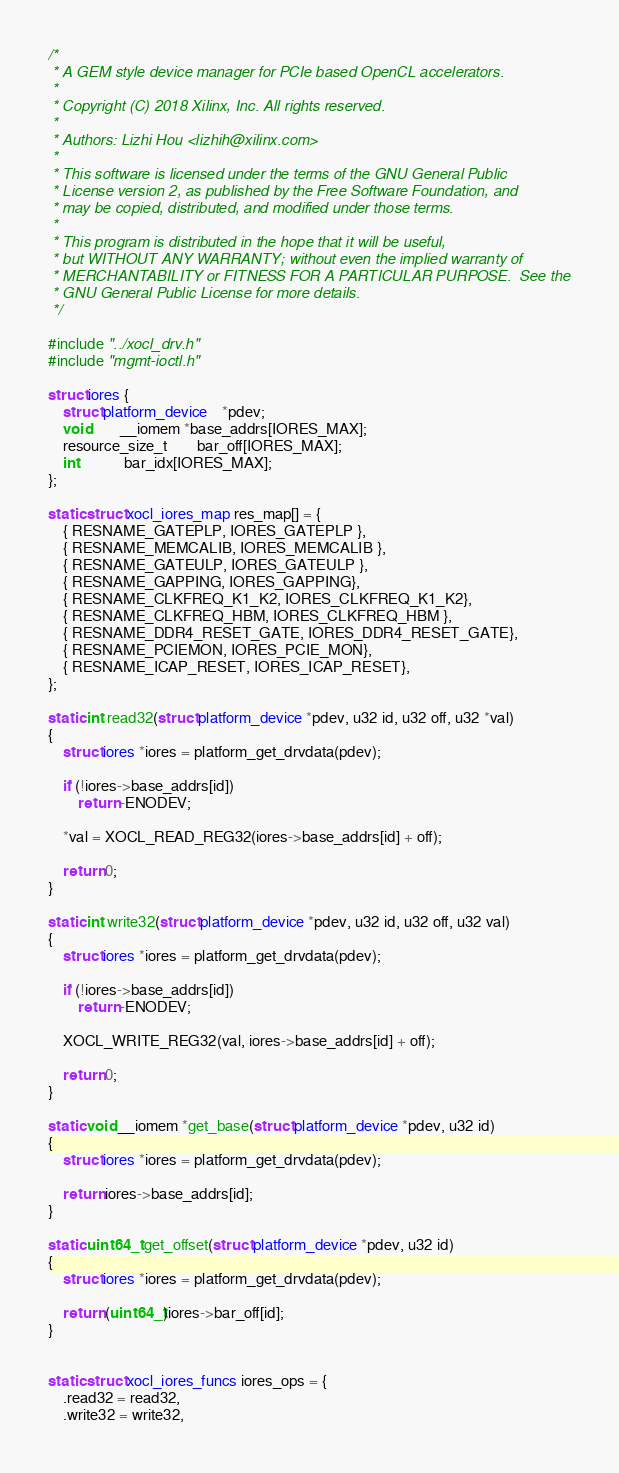<code> <loc_0><loc_0><loc_500><loc_500><_C_>/*
 * A GEM style device manager for PCIe based OpenCL accelerators.
 *
 * Copyright (C) 2018 Xilinx, Inc. All rights reserved.
 *
 * Authors: Lizhi Hou <lizhih@xilinx.com>
 *
 * This software is licensed under the terms of the GNU General Public
 * License version 2, as published by the Free Software Foundation, and
 * may be copied, distributed, and modified under those terms.
 *
 * This program is distributed in the hope that it will be useful,
 * but WITHOUT ANY WARRANTY; without even the implied warranty of
 * MERCHANTABILITY or FITNESS FOR A PARTICULAR PURPOSE.  See the
 * GNU General Public License for more details.
 */

#include "../xocl_drv.h"
#include "mgmt-ioctl.h"

struct iores {
	struct platform_device	*pdev;
	void		__iomem *base_addrs[IORES_MAX];
	resource_size_t		bar_off[IORES_MAX];
	int			bar_idx[IORES_MAX];
};

static struct xocl_iores_map res_map[] = {
	{ RESNAME_GATEPLP, IORES_GATEPLP },
	{ RESNAME_MEMCALIB, IORES_MEMCALIB },
	{ RESNAME_GATEULP, IORES_GATEULP },
	{ RESNAME_GAPPING, IORES_GAPPING},
	{ RESNAME_CLKFREQ_K1_K2, IORES_CLKFREQ_K1_K2},
	{ RESNAME_CLKFREQ_HBM, IORES_CLKFREQ_HBM },
	{ RESNAME_DDR4_RESET_GATE, IORES_DDR4_RESET_GATE},
	{ RESNAME_PCIEMON, IORES_PCIE_MON},
	{ RESNAME_ICAP_RESET, IORES_ICAP_RESET},
};

static int read32(struct platform_device *pdev, u32 id, u32 off, u32 *val)
{
	struct iores *iores = platform_get_drvdata(pdev);

	if (!iores->base_addrs[id])
		return -ENODEV;

	*val = XOCL_READ_REG32(iores->base_addrs[id] + off);

	return 0;
}

static int write32(struct platform_device *pdev, u32 id, u32 off, u32 val)
{
	struct iores *iores = platform_get_drvdata(pdev);

	if (!iores->base_addrs[id])
		return -ENODEV;

	XOCL_WRITE_REG32(val, iores->base_addrs[id] + off);

	return 0;
}

static void __iomem *get_base(struct platform_device *pdev, u32 id)
{
	struct iores *iores = platform_get_drvdata(pdev);

	return iores->base_addrs[id];
}

static uint64_t get_offset(struct platform_device *pdev, u32 id)
{
	struct iores *iores = platform_get_drvdata(pdev);

	return (uint64_t)iores->bar_off[id];
}


static struct xocl_iores_funcs iores_ops = {
	.read32 = read32,
	.write32 = write32,</code> 